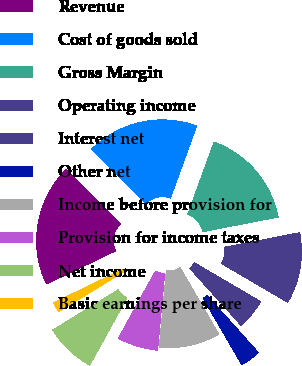Convert chart. <chart><loc_0><loc_0><loc_500><loc_500><pie_chart><fcel>Revenue<fcel>Cost of goods sold<fcel>Gross Margin<fcel>Operating income<fcel>Interest net<fcel>Other net<fcel>Income before provision for<fcel>Provision for income taxes<fcel>Net income<fcel>Basic earnings per share<nl><fcel>19.67%<fcel>18.03%<fcel>16.39%<fcel>11.48%<fcel>4.92%<fcel>3.28%<fcel>9.84%<fcel>6.56%<fcel>8.2%<fcel>1.64%<nl></chart> 